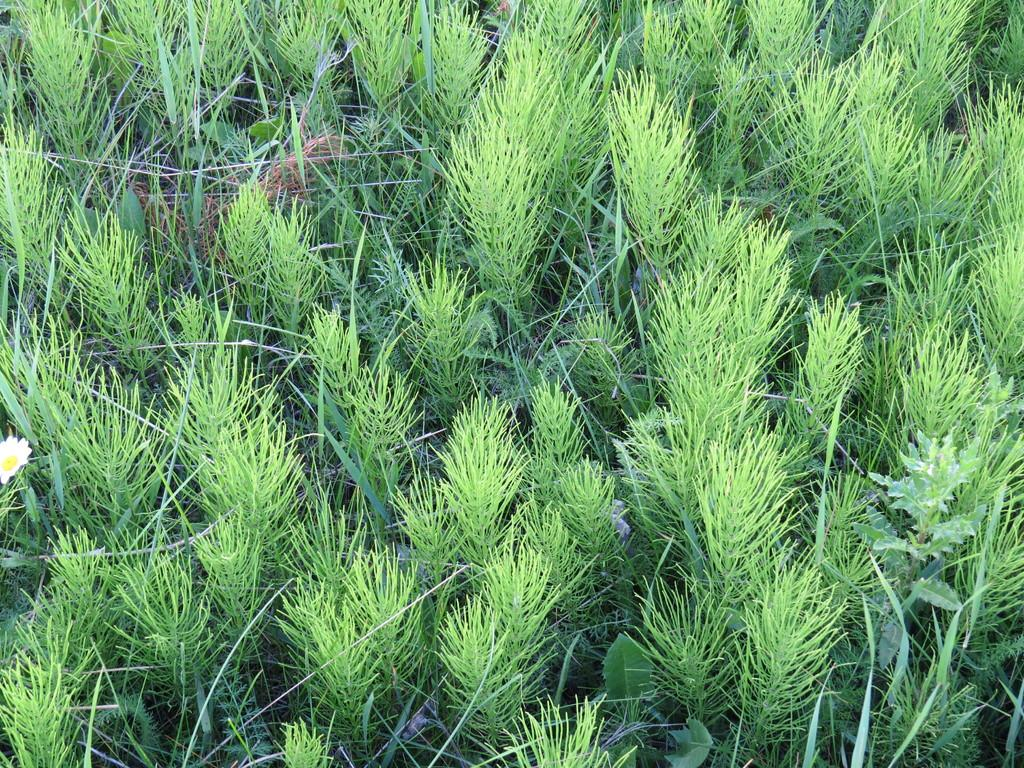What type of vegetation can be seen in the image? There are plants and grass in the image. Can you identify any specific type of plant in the image? Yes, there is a flower in the image. What type of music is being played in the background of the image? There is no indication of music being played in the image, as it focuses on the vegetation. 